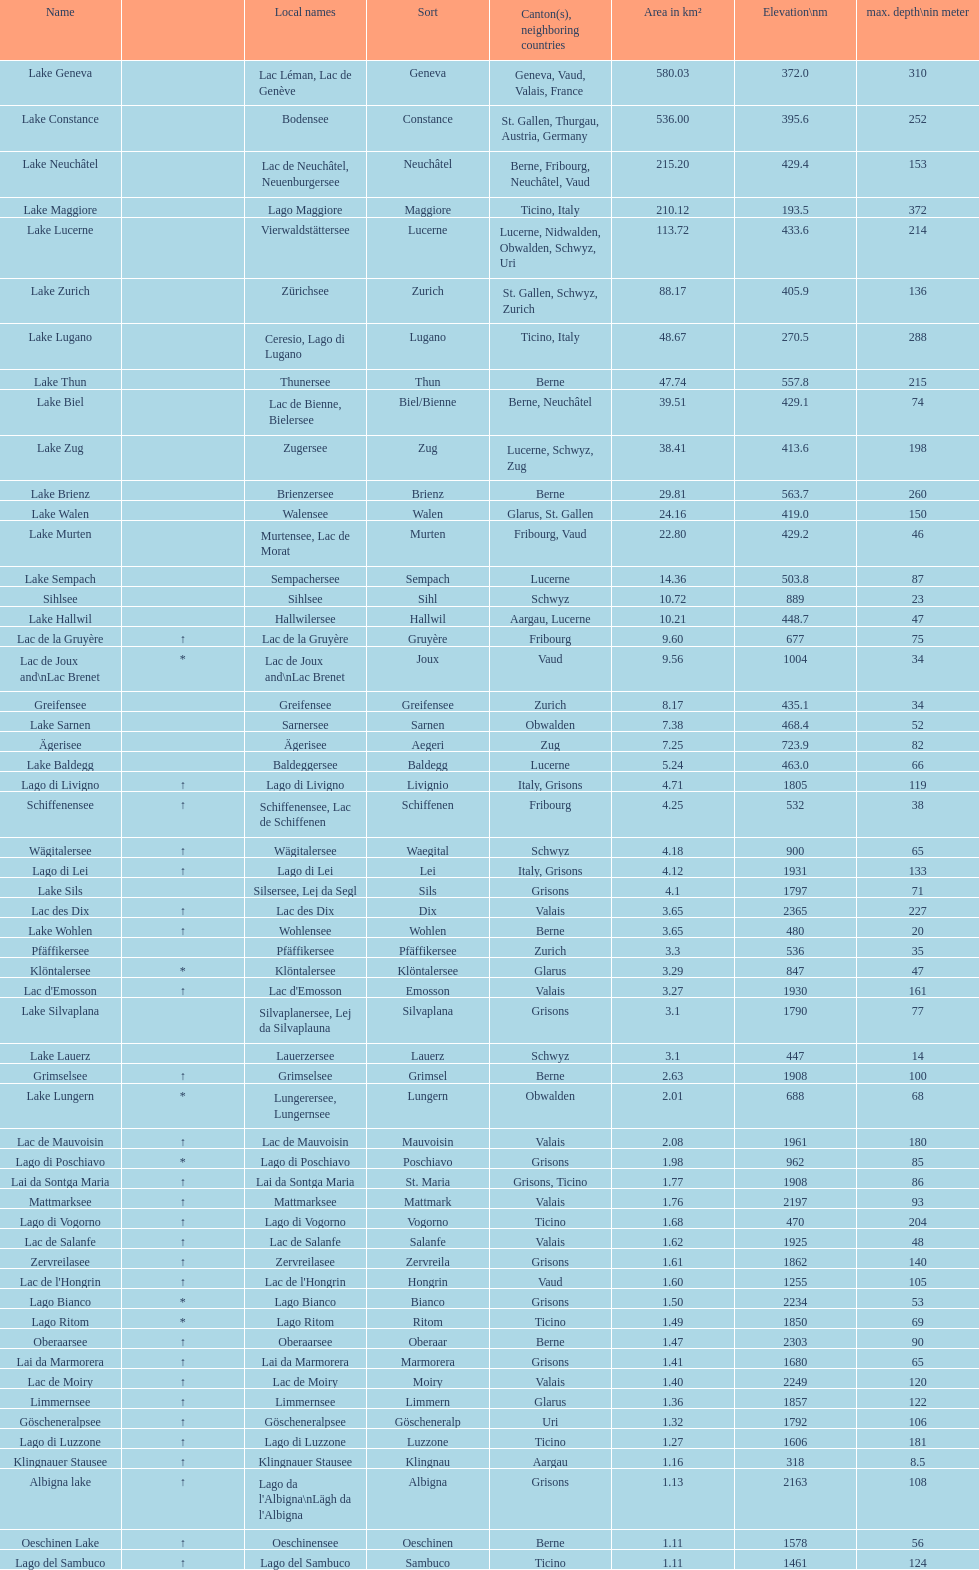After lac des dix, which lake has the second-highest elevation? Oberaarsee. 